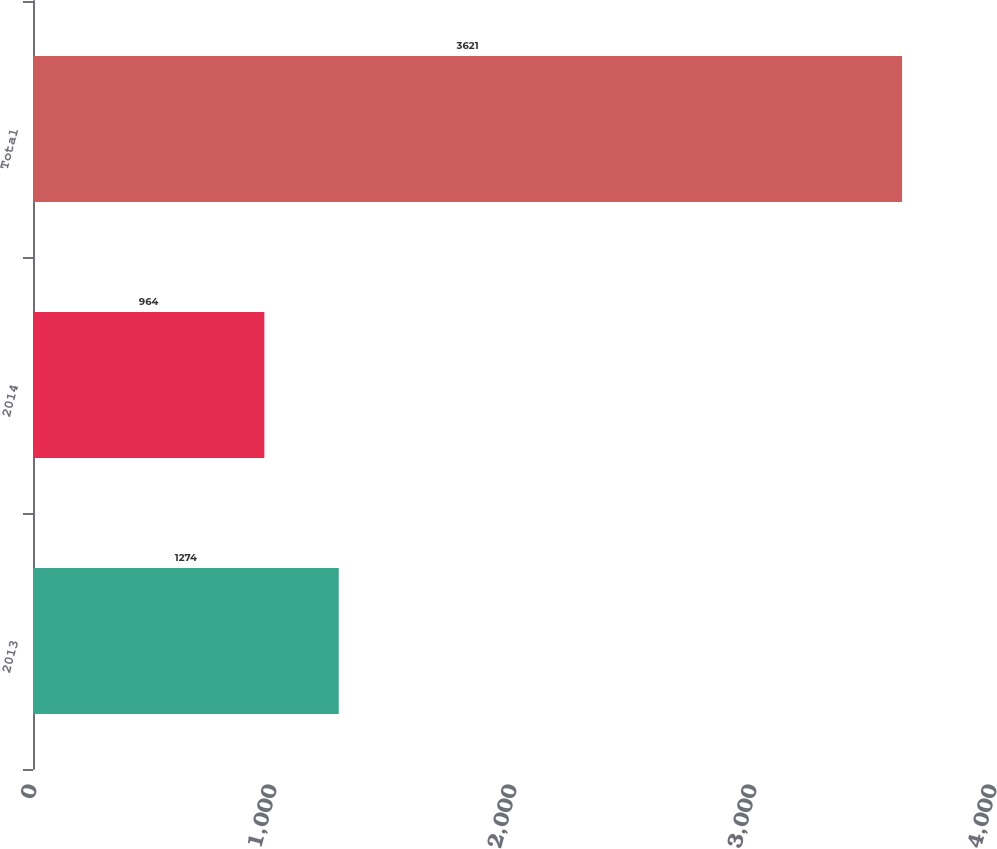Convert chart. <chart><loc_0><loc_0><loc_500><loc_500><bar_chart><fcel>2013<fcel>2014<fcel>Total<nl><fcel>1274<fcel>964<fcel>3621<nl></chart> 